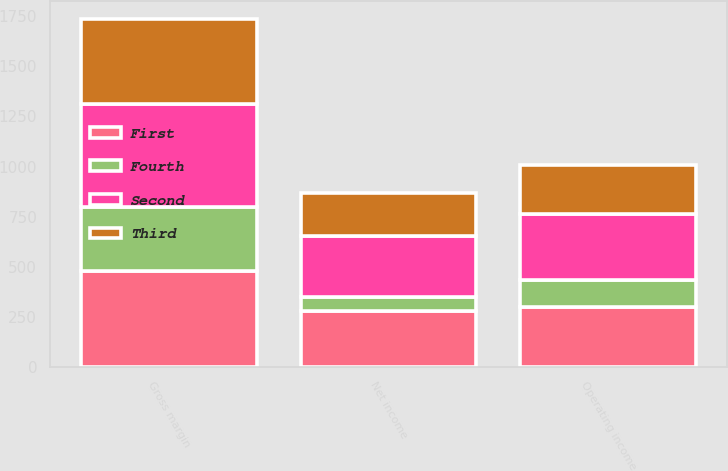Convert chart. <chart><loc_0><loc_0><loc_500><loc_500><stacked_bar_chart><ecel><fcel>Gross margin<fcel>Operating income<fcel>Net income<nl><fcel>Fourth<fcel>323<fcel>135<fcel>69<nl><fcel>Second<fcel>513<fcel>332<fcel>305<nl><fcel>First<fcel>477<fcel>298<fcel>280<nl><fcel>Third<fcel>425<fcel>241<fcel>213<nl></chart> 